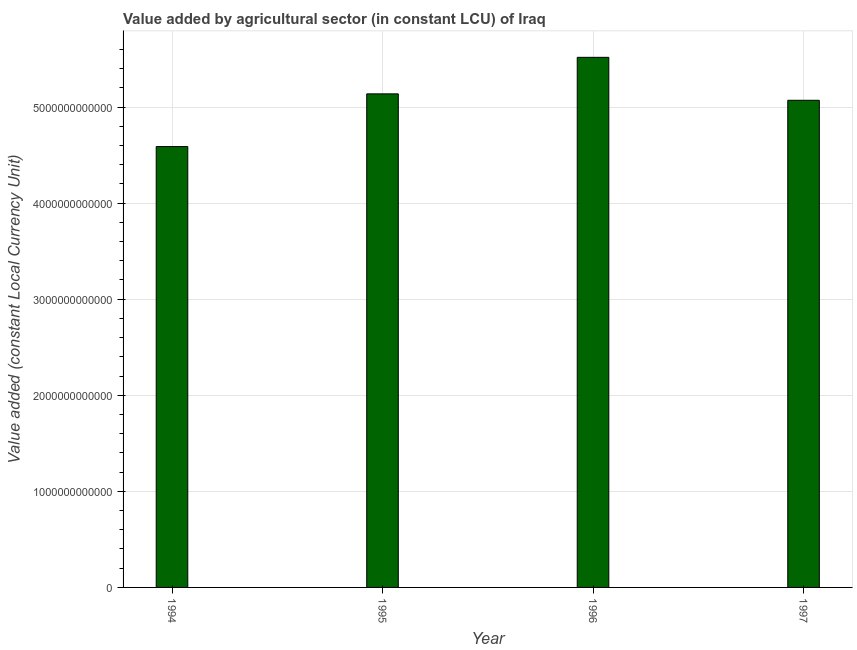Does the graph contain any zero values?
Give a very brief answer. No. Does the graph contain grids?
Ensure brevity in your answer.  Yes. What is the title of the graph?
Provide a short and direct response. Value added by agricultural sector (in constant LCU) of Iraq. What is the label or title of the X-axis?
Keep it short and to the point. Year. What is the label or title of the Y-axis?
Your answer should be compact. Value added (constant Local Currency Unit). What is the value added by agriculture sector in 1994?
Offer a terse response. 4.59e+12. Across all years, what is the maximum value added by agriculture sector?
Keep it short and to the point. 5.52e+12. Across all years, what is the minimum value added by agriculture sector?
Provide a short and direct response. 4.59e+12. In which year was the value added by agriculture sector minimum?
Offer a terse response. 1994. What is the sum of the value added by agriculture sector?
Provide a short and direct response. 2.03e+13. What is the difference between the value added by agriculture sector in 1995 and 1997?
Give a very brief answer. 6.67e+1. What is the average value added by agriculture sector per year?
Provide a short and direct response. 5.08e+12. What is the median value added by agriculture sector?
Ensure brevity in your answer.  5.10e+12. In how many years, is the value added by agriculture sector greater than 4400000000000 LCU?
Make the answer very short. 4. What is the ratio of the value added by agriculture sector in 1994 to that in 1997?
Make the answer very short. 0.91. Is the value added by agriculture sector in 1994 less than that in 1996?
Your response must be concise. Yes. What is the difference between the highest and the second highest value added by agriculture sector?
Give a very brief answer. 3.80e+11. Is the sum of the value added by agriculture sector in 1994 and 1995 greater than the maximum value added by agriculture sector across all years?
Make the answer very short. Yes. What is the difference between the highest and the lowest value added by agriculture sector?
Make the answer very short. 9.29e+11. Are all the bars in the graph horizontal?
Provide a succinct answer. No. What is the difference between two consecutive major ticks on the Y-axis?
Provide a succinct answer. 1.00e+12. Are the values on the major ticks of Y-axis written in scientific E-notation?
Ensure brevity in your answer.  No. What is the Value added (constant Local Currency Unit) in 1994?
Offer a very short reply. 4.59e+12. What is the Value added (constant Local Currency Unit) in 1995?
Ensure brevity in your answer.  5.14e+12. What is the Value added (constant Local Currency Unit) of 1996?
Provide a short and direct response. 5.52e+12. What is the Value added (constant Local Currency Unit) of 1997?
Give a very brief answer. 5.07e+12. What is the difference between the Value added (constant Local Currency Unit) in 1994 and 1995?
Make the answer very short. -5.48e+11. What is the difference between the Value added (constant Local Currency Unit) in 1994 and 1996?
Your response must be concise. -9.29e+11. What is the difference between the Value added (constant Local Currency Unit) in 1994 and 1997?
Your answer should be compact. -4.82e+11. What is the difference between the Value added (constant Local Currency Unit) in 1995 and 1996?
Your answer should be compact. -3.80e+11. What is the difference between the Value added (constant Local Currency Unit) in 1995 and 1997?
Ensure brevity in your answer.  6.67e+1. What is the difference between the Value added (constant Local Currency Unit) in 1996 and 1997?
Offer a very short reply. 4.47e+11. What is the ratio of the Value added (constant Local Currency Unit) in 1994 to that in 1995?
Give a very brief answer. 0.89. What is the ratio of the Value added (constant Local Currency Unit) in 1994 to that in 1996?
Give a very brief answer. 0.83. What is the ratio of the Value added (constant Local Currency Unit) in 1994 to that in 1997?
Offer a terse response. 0.91. What is the ratio of the Value added (constant Local Currency Unit) in 1995 to that in 1996?
Provide a succinct answer. 0.93. What is the ratio of the Value added (constant Local Currency Unit) in 1996 to that in 1997?
Offer a very short reply. 1.09. 